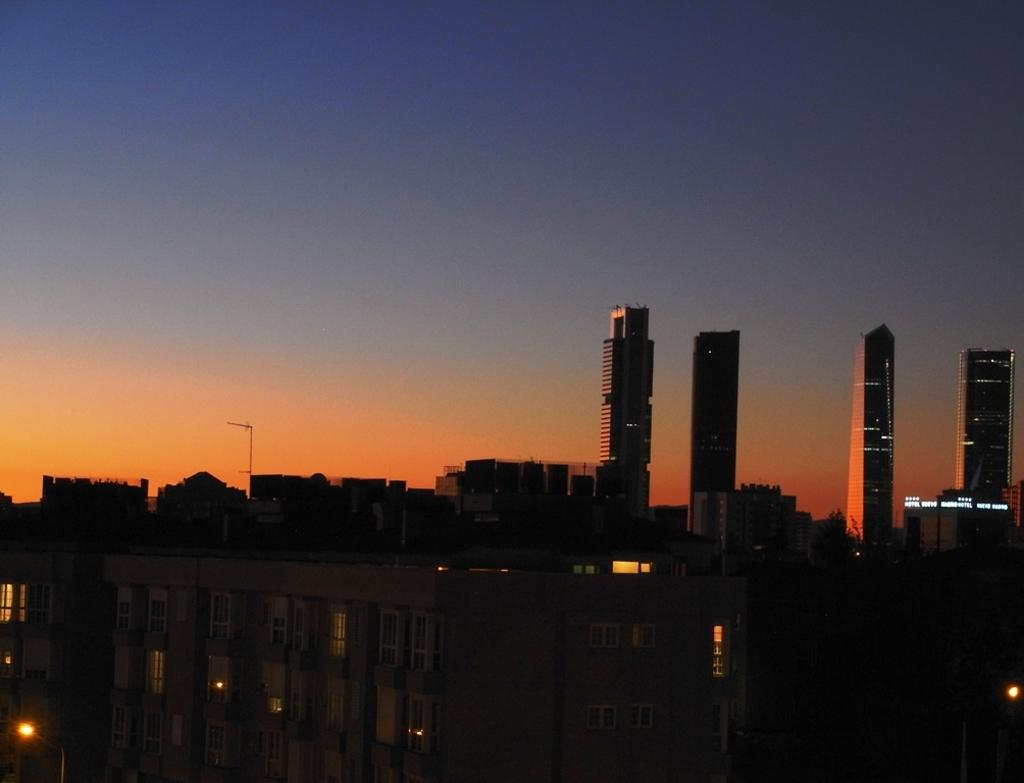What type of structures can be seen in the image? There are buildings in the image. How many tower buildings are visible in the background? There are four tower buildings in the background of the image. Who won the competition between the four tower buildings in the image? There is no competition mentioned in the image, so it cannot be determined who won. 